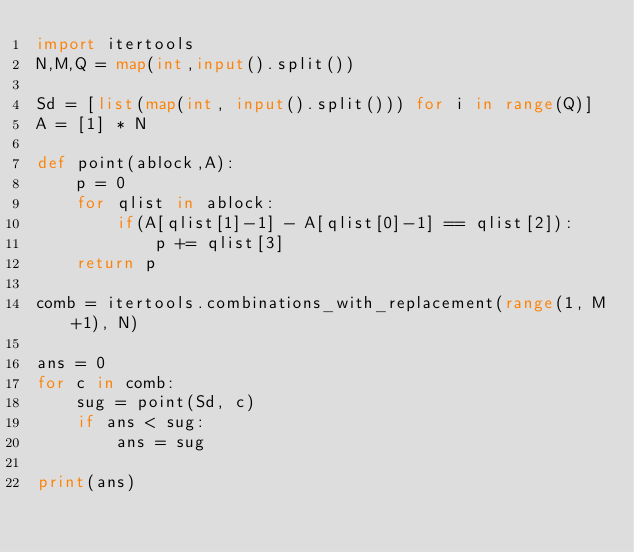Convert code to text. <code><loc_0><loc_0><loc_500><loc_500><_Python_>import itertools
N,M,Q = map(int,input().split())

Sd = [list(map(int, input().split())) for i in range(Q)]
A = [1] * N

def point(ablock,A):
    p = 0
    for qlist in ablock:
        if(A[qlist[1]-1] - A[qlist[0]-1] == qlist[2]):
            p += qlist[3]
    return p

comb = itertools.combinations_with_replacement(range(1, M+1), N)

ans = 0
for c in comb:
    sug = point(Sd, c)
    if ans < sug:
        ans = sug

print(ans)</code> 